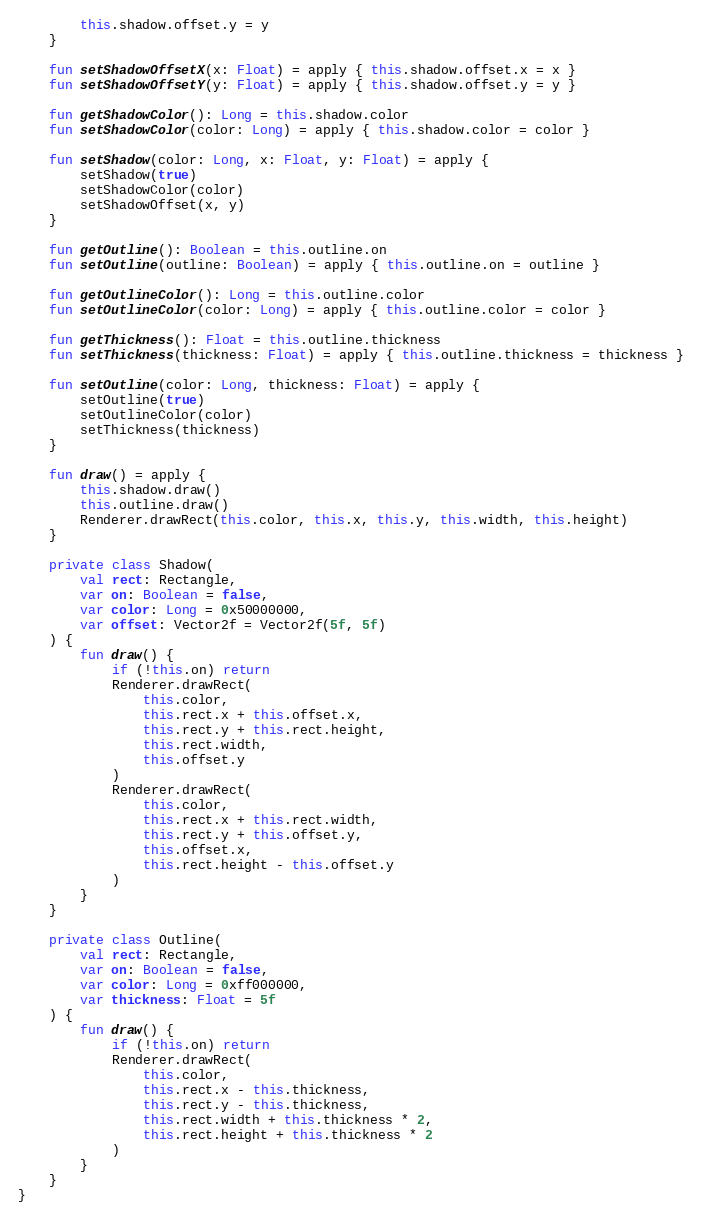Convert code to text. <code><loc_0><loc_0><loc_500><loc_500><_Kotlin_>        this.shadow.offset.y = y
    }

    fun setShadowOffsetX(x: Float) = apply { this.shadow.offset.x = x }
    fun setShadowOffsetY(y: Float) = apply { this.shadow.offset.y = y }

    fun getShadowColor(): Long = this.shadow.color
    fun setShadowColor(color: Long) = apply { this.shadow.color = color }

    fun setShadow(color: Long, x: Float, y: Float) = apply {
        setShadow(true)
        setShadowColor(color)
        setShadowOffset(x, y)
    }

    fun getOutline(): Boolean = this.outline.on
    fun setOutline(outline: Boolean) = apply { this.outline.on = outline }

    fun getOutlineColor(): Long = this.outline.color
    fun setOutlineColor(color: Long) = apply { this.outline.color = color }

    fun getThickness(): Float = this.outline.thickness
    fun setThickness(thickness: Float) = apply { this.outline.thickness = thickness }

    fun setOutline(color: Long, thickness: Float) = apply {
        setOutline(true)
        setOutlineColor(color)
        setThickness(thickness)
    }

    fun draw() = apply {
        this.shadow.draw()
        this.outline.draw()
        Renderer.drawRect(this.color, this.x, this.y, this.width, this.height)
    }

    private class Shadow(
        val rect: Rectangle,
        var on: Boolean = false,
        var color: Long = 0x50000000,
        var offset: Vector2f = Vector2f(5f, 5f)
    ) {
        fun draw() {
            if (!this.on) return
            Renderer.drawRect(
                this.color,
                this.rect.x + this.offset.x,
                this.rect.y + this.rect.height,
                this.rect.width,
                this.offset.y
            )
            Renderer.drawRect(
                this.color,
                this.rect.x + this.rect.width,
                this.rect.y + this.offset.y,
                this.offset.x,
                this.rect.height - this.offset.y
            )
        }
    }

    private class Outline(
        val rect: Rectangle,
        var on: Boolean = false,
        var color: Long = 0xff000000,
        var thickness: Float = 5f
    ) {
        fun draw() {
            if (!this.on) return
            Renderer.drawRect(
                this.color,
                this.rect.x - this.thickness,
                this.rect.y - this.thickness,
                this.rect.width + this.thickness * 2,
                this.rect.height + this.thickness * 2
            )
        }
    }
}</code> 